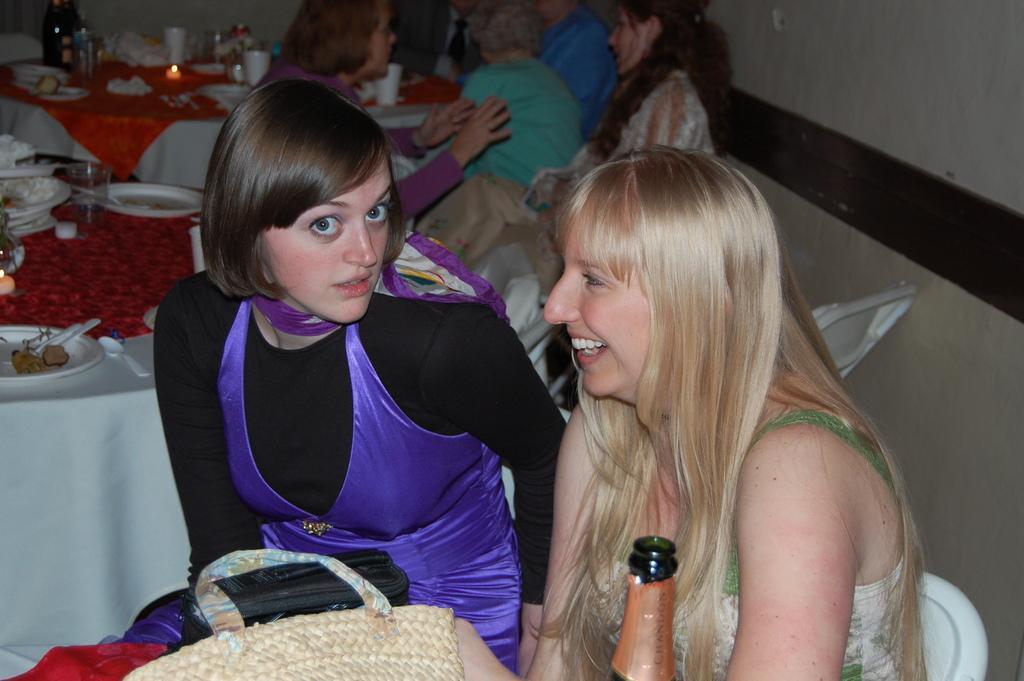Could you give a brief overview of what you see in this image? This picture shows few women seated on the chairs and we see plates, spoons and glasses on the couple of tables and we see a bottle and a bag 